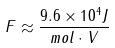<formula> <loc_0><loc_0><loc_500><loc_500>F \approx \frac { 9 . 6 \times 1 0 ^ { 4 } J } { m o l \cdot V }</formula> 